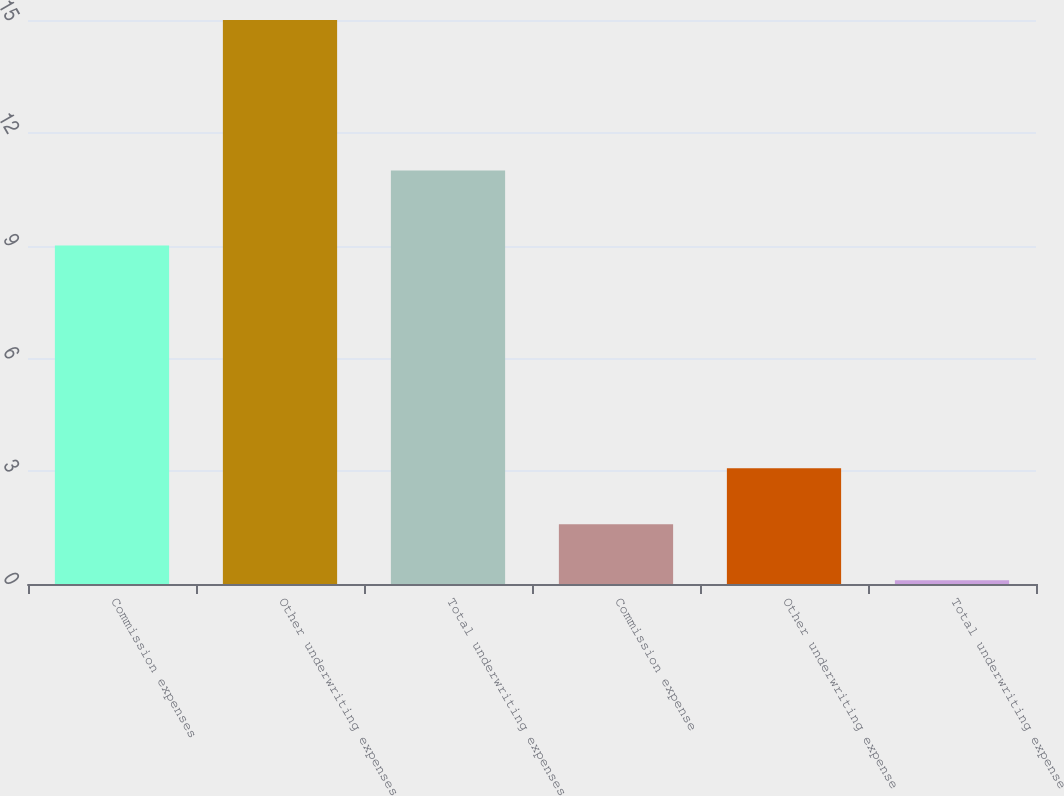<chart> <loc_0><loc_0><loc_500><loc_500><bar_chart><fcel>Commission expenses<fcel>Other underwriting expenses<fcel>Total underwriting expenses<fcel>Commission expense<fcel>Other underwriting expense<fcel>Total underwriting expense<nl><fcel>9<fcel>15<fcel>11<fcel>1.59<fcel>3.08<fcel>0.1<nl></chart> 